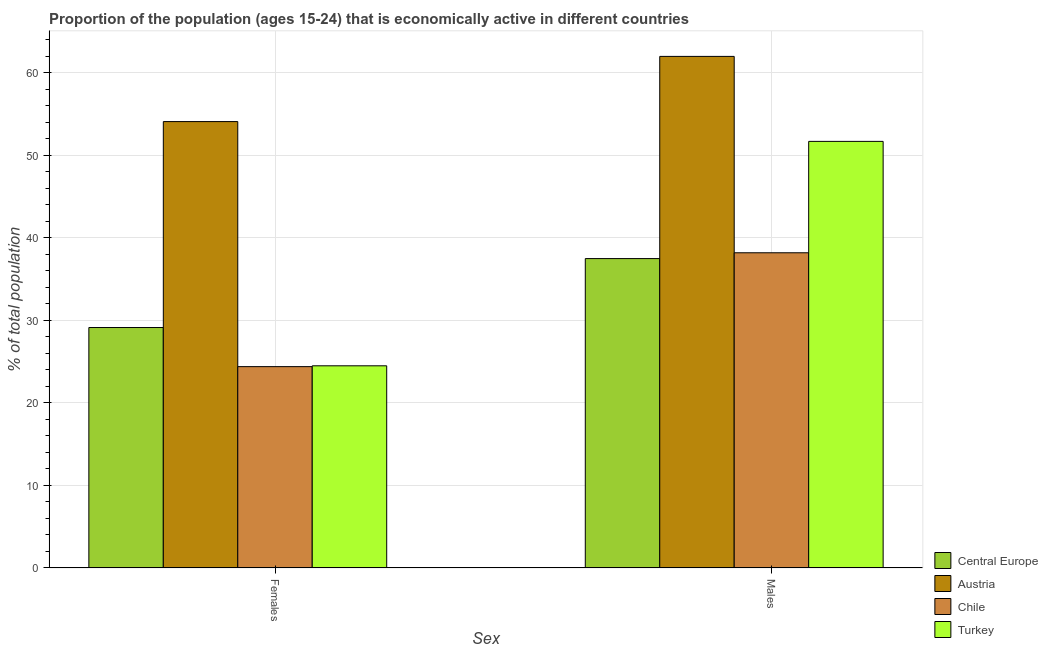How many different coloured bars are there?
Ensure brevity in your answer.  4. How many groups of bars are there?
Your response must be concise. 2. Are the number of bars on each tick of the X-axis equal?
Make the answer very short. Yes. What is the label of the 2nd group of bars from the left?
Your response must be concise. Males. What is the percentage of economically active female population in Chile?
Your answer should be very brief. 24.4. Across all countries, what is the maximum percentage of economically active female population?
Give a very brief answer. 54.1. Across all countries, what is the minimum percentage of economically active female population?
Offer a terse response. 24.4. In which country was the percentage of economically active male population minimum?
Offer a very short reply. Central Europe. What is the total percentage of economically active male population in the graph?
Give a very brief answer. 189.39. What is the difference between the percentage of economically active male population in Chile and that in Central Europe?
Offer a terse response. 0.71. What is the difference between the percentage of economically active female population in Central Europe and the percentage of economically active male population in Turkey?
Offer a very short reply. -22.56. What is the average percentage of economically active male population per country?
Your answer should be very brief. 47.35. What is the difference between the percentage of economically active male population and percentage of economically active female population in Turkey?
Keep it short and to the point. 27.2. In how many countries, is the percentage of economically active male population greater than 58 %?
Your answer should be very brief. 1. What is the ratio of the percentage of economically active female population in Austria to that in Turkey?
Your answer should be compact. 2.21. In how many countries, is the percentage of economically active female population greater than the average percentage of economically active female population taken over all countries?
Offer a terse response. 1. What does the 3rd bar from the left in Males represents?
Keep it short and to the point. Chile. What is the difference between two consecutive major ticks on the Y-axis?
Your answer should be compact. 10. Are the values on the major ticks of Y-axis written in scientific E-notation?
Offer a terse response. No. Does the graph contain any zero values?
Provide a short and direct response. No. How many legend labels are there?
Ensure brevity in your answer.  4. What is the title of the graph?
Provide a succinct answer. Proportion of the population (ages 15-24) that is economically active in different countries. What is the label or title of the X-axis?
Provide a succinct answer. Sex. What is the label or title of the Y-axis?
Provide a succinct answer. % of total population. What is the % of total population of Central Europe in Females?
Ensure brevity in your answer.  29.14. What is the % of total population of Austria in Females?
Keep it short and to the point. 54.1. What is the % of total population of Chile in Females?
Your answer should be compact. 24.4. What is the % of total population in Turkey in Females?
Offer a very short reply. 24.5. What is the % of total population of Central Europe in Males?
Make the answer very short. 37.49. What is the % of total population of Austria in Males?
Give a very brief answer. 62. What is the % of total population of Chile in Males?
Offer a very short reply. 38.2. What is the % of total population in Turkey in Males?
Your answer should be very brief. 51.7. Across all Sex, what is the maximum % of total population in Central Europe?
Your response must be concise. 37.49. Across all Sex, what is the maximum % of total population of Austria?
Provide a short and direct response. 62. Across all Sex, what is the maximum % of total population of Chile?
Keep it short and to the point. 38.2. Across all Sex, what is the maximum % of total population in Turkey?
Provide a succinct answer. 51.7. Across all Sex, what is the minimum % of total population of Central Europe?
Keep it short and to the point. 29.14. Across all Sex, what is the minimum % of total population of Austria?
Your answer should be very brief. 54.1. Across all Sex, what is the minimum % of total population of Chile?
Make the answer very short. 24.4. What is the total % of total population in Central Europe in the graph?
Provide a short and direct response. 66.63. What is the total % of total population of Austria in the graph?
Your answer should be very brief. 116.1. What is the total % of total population in Chile in the graph?
Provide a short and direct response. 62.6. What is the total % of total population of Turkey in the graph?
Offer a very short reply. 76.2. What is the difference between the % of total population in Central Europe in Females and that in Males?
Provide a short and direct response. -8.35. What is the difference between the % of total population of Austria in Females and that in Males?
Give a very brief answer. -7.9. What is the difference between the % of total population in Chile in Females and that in Males?
Keep it short and to the point. -13.8. What is the difference between the % of total population in Turkey in Females and that in Males?
Provide a succinct answer. -27.2. What is the difference between the % of total population of Central Europe in Females and the % of total population of Austria in Males?
Offer a terse response. -32.86. What is the difference between the % of total population in Central Europe in Females and the % of total population in Chile in Males?
Keep it short and to the point. -9.06. What is the difference between the % of total population in Central Europe in Females and the % of total population in Turkey in Males?
Ensure brevity in your answer.  -22.56. What is the difference between the % of total population in Austria in Females and the % of total population in Turkey in Males?
Your answer should be very brief. 2.4. What is the difference between the % of total population in Chile in Females and the % of total population in Turkey in Males?
Offer a terse response. -27.3. What is the average % of total population of Central Europe per Sex?
Give a very brief answer. 33.32. What is the average % of total population of Austria per Sex?
Provide a succinct answer. 58.05. What is the average % of total population of Chile per Sex?
Your answer should be very brief. 31.3. What is the average % of total population in Turkey per Sex?
Keep it short and to the point. 38.1. What is the difference between the % of total population in Central Europe and % of total population in Austria in Females?
Your answer should be compact. -24.96. What is the difference between the % of total population in Central Europe and % of total population in Chile in Females?
Ensure brevity in your answer.  4.74. What is the difference between the % of total population in Central Europe and % of total population in Turkey in Females?
Keep it short and to the point. 4.64. What is the difference between the % of total population in Austria and % of total population in Chile in Females?
Make the answer very short. 29.7. What is the difference between the % of total population in Austria and % of total population in Turkey in Females?
Provide a succinct answer. 29.6. What is the difference between the % of total population in Chile and % of total population in Turkey in Females?
Offer a very short reply. -0.1. What is the difference between the % of total population in Central Europe and % of total population in Austria in Males?
Ensure brevity in your answer.  -24.51. What is the difference between the % of total population in Central Europe and % of total population in Chile in Males?
Make the answer very short. -0.71. What is the difference between the % of total population in Central Europe and % of total population in Turkey in Males?
Make the answer very short. -14.21. What is the difference between the % of total population of Austria and % of total population of Chile in Males?
Make the answer very short. 23.8. What is the difference between the % of total population of Austria and % of total population of Turkey in Males?
Your answer should be very brief. 10.3. What is the ratio of the % of total population in Central Europe in Females to that in Males?
Provide a short and direct response. 0.78. What is the ratio of the % of total population in Austria in Females to that in Males?
Ensure brevity in your answer.  0.87. What is the ratio of the % of total population of Chile in Females to that in Males?
Provide a short and direct response. 0.64. What is the ratio of the % of total population of Turkey in Females to that in Males?
Provide a short and direct response. 0.47. What is the difference between the highest and the second highest % of total population in Central Europe?
Give a very brief answer. 8.35. What is the difference between the highest and the second highest % of total population in Chile?
Give a very brief answer. 13.8. What is the difference between the highest and the second highest % of total population of Turkey?
Provide a short and direct response. 27.2. What is the difference between the highest and the lowest % of total population of Central Europe?
Offer a terse response. 8.35. What is the difference between the highest and the lowest % of total population in Austria?
Give a very brief answer. 7.9. What is the difference between the highest and the lowest % of total population of Turkey?
Make the answer very short. 27.2. 